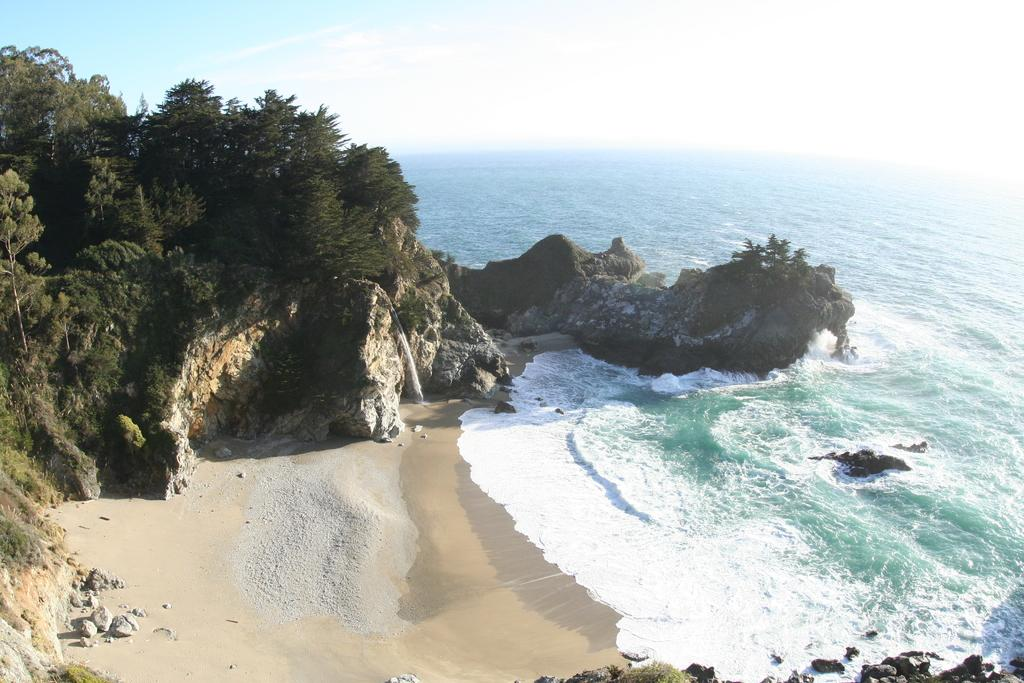Where was the image taken? The image was clicked near the ocean. What can be seen to the right of the image? There is water visible to the right. What type of vegetation is present in the image? There are trees in the image. What geographical feature can be seen in the background? There are mountains in the image. What flavor of picture is being displayed in the image? The image is not a picture with a flavor; it is a photograph of a natural scene. Can you see a rake in the image? There is no rake present in the image. 